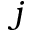<formula> <loc_0><loc_0><loc_500><loc_500>j</formula> 